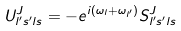Convert formula to latex. <formula><loc_0><loc_0><loc_500><loc_500>U ^ { J } _ { l ^ { \prime } s ^ { \prime } l s } = - e ^ { i ( \omega _ { l } + \omega _ { l ^ { \prime } } ) } S ^ { J } _ { l ^ { \prime } s ^ { \prime } l s }</formula> 